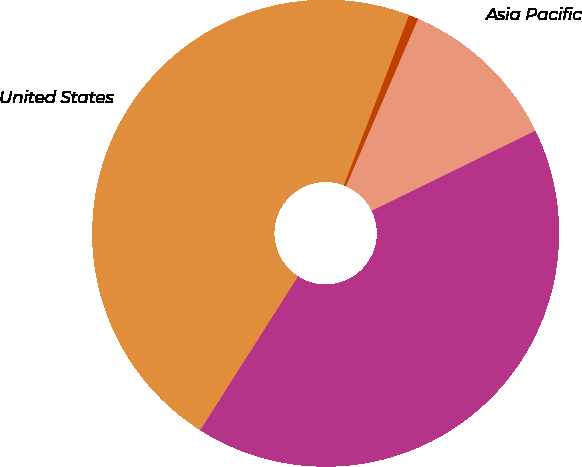Convert chart. <chart><loc_0><loc_0><loc_500><loc_500><pie_chart><fcel>United States<fcel>Europe Middle East Africa<fcel>Asia Pacific<fcel>Other foreign countries<nl><fcel>46.81%<fcel>41.26%<fcel>11.29%<fcel>0.65%<nl></chart> 